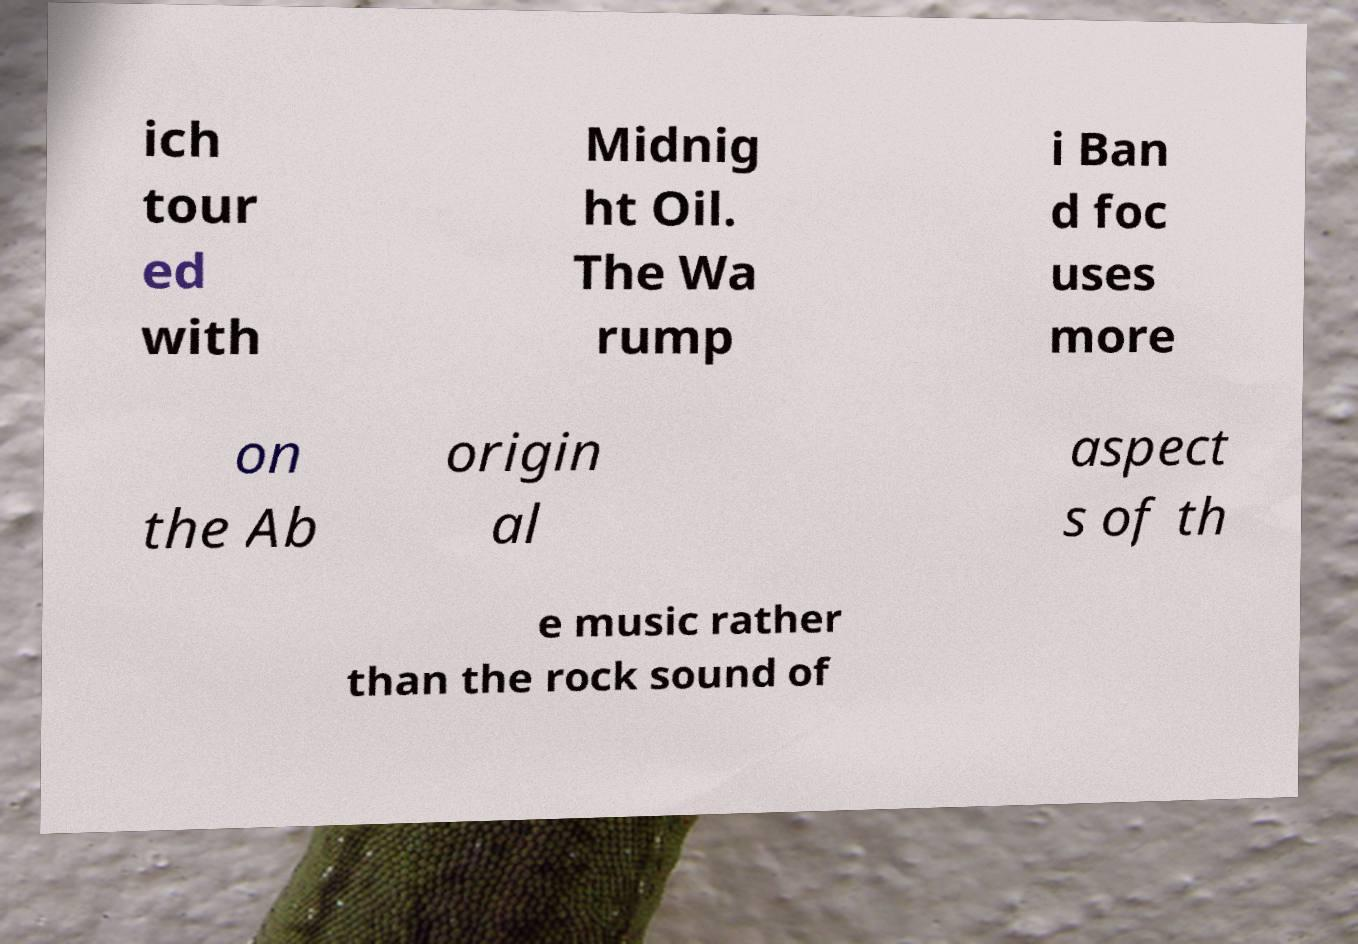Please read and relay the text visible in this image. What does it say? ich tour ed with Midnig ht Oil. The Wa rump i Ban d foc uses more on the Ab origin al aspect s of th e music rather than the rock sound of 